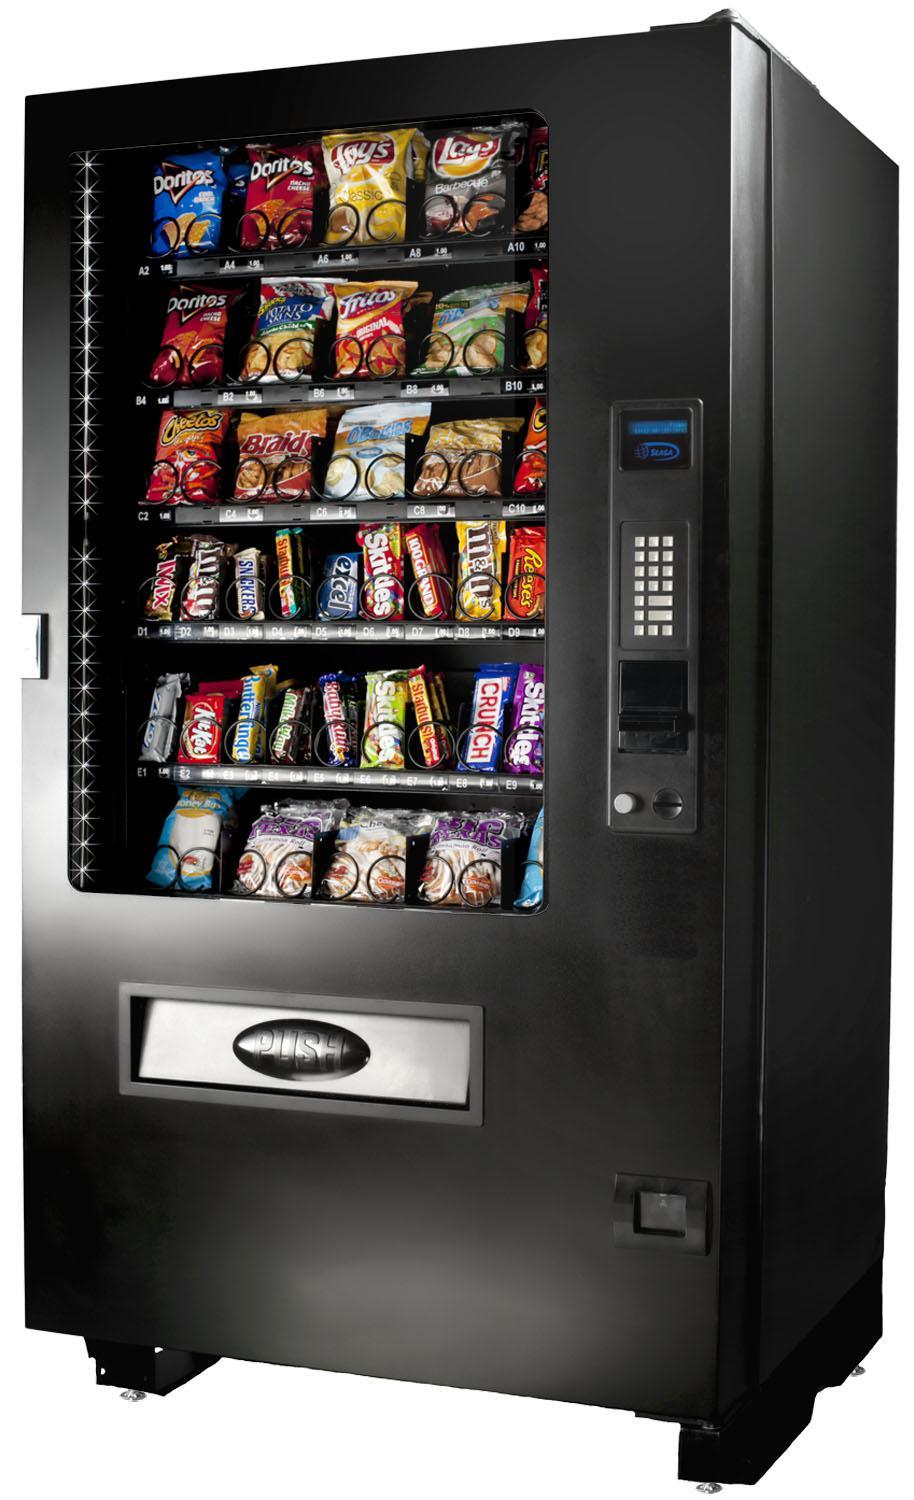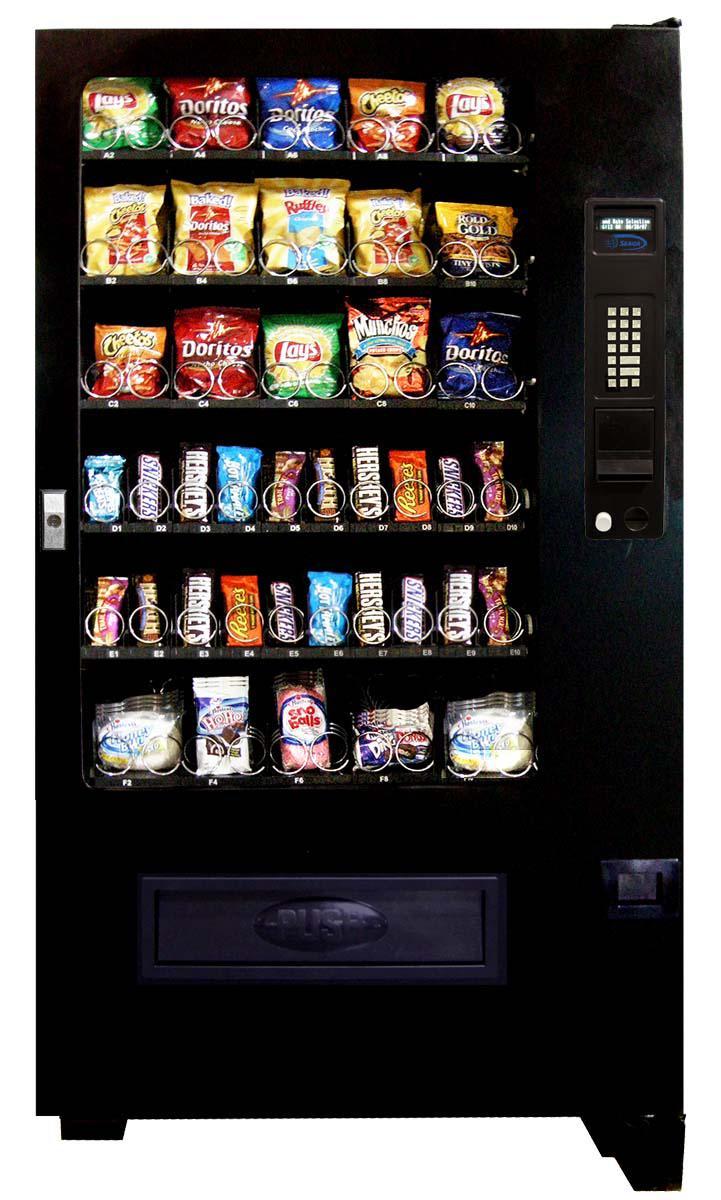The first image is the image on the left, the second image is the image on the right. Evaluate the accuracy of this statement regarding the images: "The dispensing port of the vending machine in the image on the right is outlined in gray.". Is it true? Answer yes or no. No. 